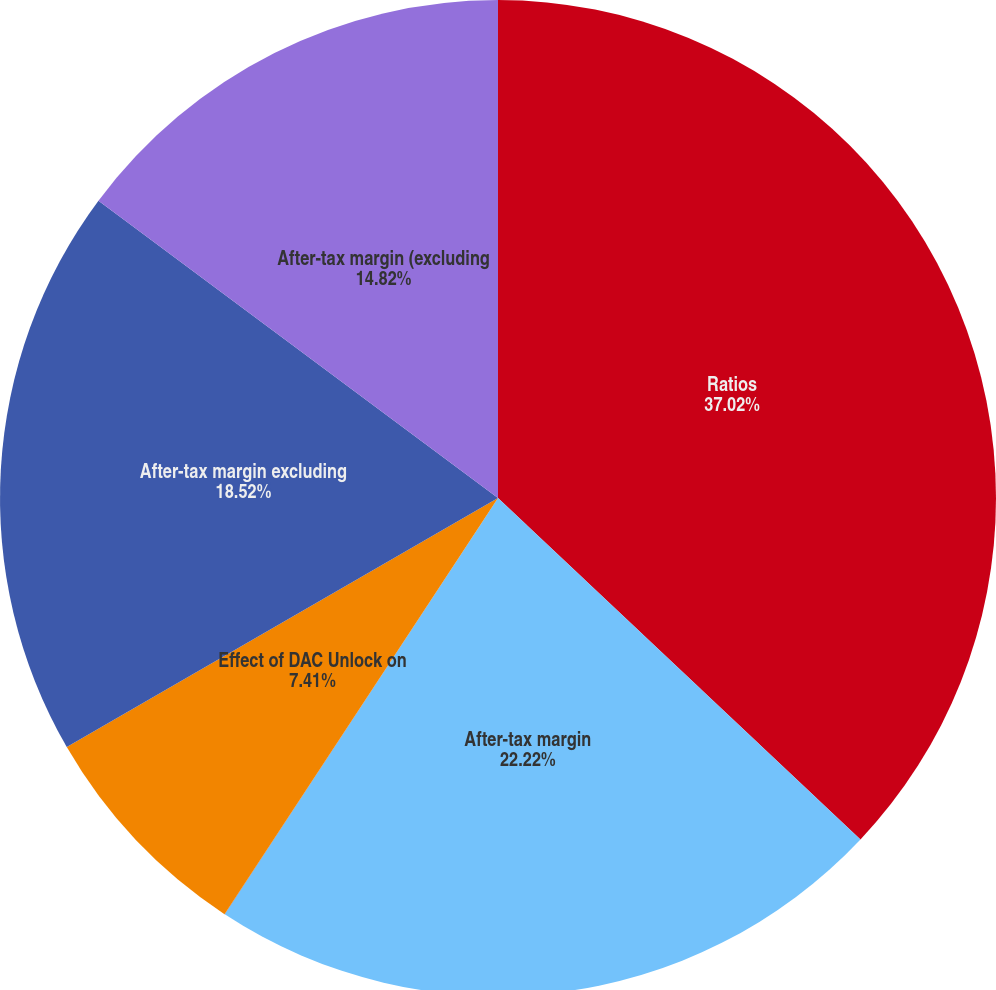<chart> <loc_0><loc_0><loc_500><loc_500><pie_chart><fcel>Ratios<fcel>After-tax margin<fcel>Effect of net realized gains<fcel>Effect of DAC Unlock on<fcel>After-tax margin excluding<fcel>After-tax margin (excluding<nl><fcel>37.03%<fcel>22.22%<fcel>0.01%<fcel>7.41%<fcel>18.52%<fcel>14.82%<nl></chart> 